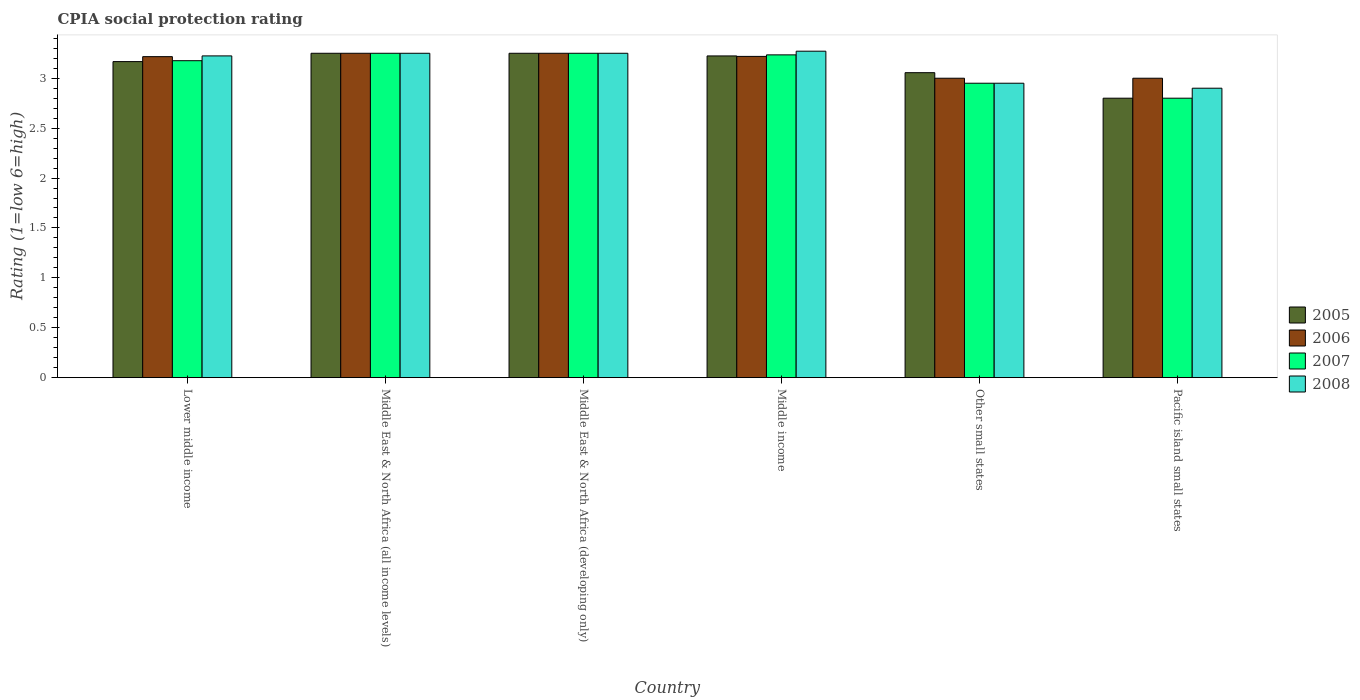How many different coloured bars are there?
Offer a terse response. 4. How many bars are there on the 1st tick from the left?
Ensure brevity in your answer.  4. What is the label of the 2nd group of bars from the left?
Provide a succinct answer. Middle East & North Africa (all income levels). In how many cases, is the number of bars for a given country not equal to the number of legend labels?
Keep it short and to the point. 0. What is the CPIA rating in 2005 in Middle income?
Keep it short and to the point. 3.22. In which country was the CPIA rating in 2008 maximum?
Provide a short and direct response. Middle income. In which country was the CPIA rating in 2006 minimum?
Offer a terse response. Other small states. What is the total CPIA rating in 2007 in the graph?
Keep it short and to the point. 18.66. What is the difference between the CPIA rating in 2008 in Middle East & North Africa (all income levels) and that in Middle East & North Africa (developing only)?
Your response must be concise. 0. What is the difference between the CPIA rating in 2007 in Lower middle income and the CPIA rating in 2006 in Middle income?
Provide a succinct answer. -0.04. What is the average CPIA rating in 2007 per country?
Make the answer very short. 3.11. What is the difference between the CPIA rating of/in 2006 and CPIA rating of/in 2008 in Middle income?
Offer a very short reply. -0.05. In how many countries, is the CPIA rating in 2005 greater than 0.8?
Give a very brief answer. 6. What is the ratio of the CPIA rating in 2005 in Other small states to that in Pacific island small states?
Provide a succinct answer. 1.09. What is the difference between the highest and the second highest CPIA rating in 2005?
Your answer should be very brief. -0.03. What is the difference between the highest and the lowest CPIA rating in 2007?
Offer a terse response. 0.45. Is the sum of the CPIA rating in 2006 in Middle East & North Africa (developing only) and Middle income greater than the maximum CPIA rating in 2008 across all countries?
Offer a very short reply. Yes. How many bars are there?
Your answer should be very brief. 24. Are all the bars in the graph horizontal?
Make the answer very short. No. What is the difference between two consecutive major ticks on the Y-axis?
Give a very brief answer. 0.5. Are the values on the major ticks of Y-axis written in scientific E-notation?
Your answer should be very brief. No. Does the graph contain any zero values?
Give a very brief answer. No. Does the graph contain grids?
Provide a short and direct response. No. Where does the legend appear in the graph?
Ensure brevity in your answer.  Center right. How many legend labels are there?
Provide a short and direct response. 4. What is the title of the graph?
Give a very brief answer. CPIA social protection rating. Does "2007" appear as one of the legend labels in the graph?
Offer a terse response. Yes. What is the label or title of the X-axis?
Provide a succinct answer. Country. What is the label or title of the Y-axis?
Provide a succinct answer. Rating (1=low 6=high). What is the Rating (1=low 6=high) of 2005 in Lower middle income?
Provide a short and direct response. 3.17. What is the Rating (1=low 6=high) of 2006 in Lower middle income?
Make the answer very short. 3.22. What is the Rating (1=low 6=high) of 2007 in Lower middle income?
Your response must be concise. 3.18. What is the Rating (1=low 6=high) in 2008 in Lower middle income?
Give a very brief answer. 3.22. What is the Rating (1=low 6=high) of 2007 in Middle East & North Africa (all income levels)?
Your answer should be very brief. 3.25. What is the Rating (1=low 6=high) in 2007 in Middle East & North Africa (developing only)?
Ensure brevity in your answer.  3.25. What is the Rating (1=low 6=high) of 2005 in Middle income?
Provide a succinct answer. 3.22. What is the Rating (1=low 6=high) of 2006 in Middle income?
Give a very brief answer. 3.22. What is the Rating (1=low 6=high) of 2007 in Middle income?
Your answer should be compact. 3.23. What is the Rating (1=low 6=high) of 2008 in Middle income?
Make the answer very short. 3.27. What is the Rating (1=low 6=high) in 2005 in Other small states?
Ensure brevity in your answer.  3.06. What is the Rating (1=low 6=high) of 2007 in Other small states?
Offer a terse response. 2.95. What is the Rating (1=low 6=high) of 2008 in Other small states?
Keep it short and to the point. 2.95. What is the Rating (1=low 6=high) of 2005 in Pacific island small states?
Provide a succinct answer. 2.8. What is the Rating (1=low 6=high) in 2008 in Pacific island small states?
Make the answer very short. 2.9. Across all countries, what is the maximum Rating (1=low 6=high) in 2005?
Offer a terse response. 3.25. Across all countries, what is the maximum Rating (1=low 6=high) of 2006?
Your answer should be very brief. 3.25. Across all countries, what is the maximum Rating (1=low 6=high) of 2007?
Offer a terse response. 3.25. Across all countries, what is the maximum Rating (1=low 6=high) of 2008?
Offer a terse response. 3.27. Across all countries, what is the minimum Rating (1=low 6=high) in 2006?
Your answer should be compact. 3. Across all countries, what is the minimum Rating (1=low 6=high) in 2007?
Your answer should be very brief. 2.8. Across all countries, what is the minimum Rating (1=low 6=high) in 2008?
Ensure brevity in your answer.  2.9. What is the total Rating (1=low 6=high) of 2005 in the graph?
Provide a succinct answer. 18.75. What is the total Rating (1=low 6=high) in 2006 in the graph?
Offer a terse response. 18.93. What is the total Rating (1=low 6=high) of 2007 in the graph?
Provide a succinct answer. 18.66. What is the total Rating (1=low 6=high) of 2008 in the graph?
Keep it short and to the point. 18.84. What is the difference between the Rating (1=low 6=high) in 2005 in Lower middle income and that in Middle East & North Africa (all income levels)?
Your answer should be compact. -0.08. What is the difference between the Rating (1=low 6=high) in 2006 in Lower middle income and that in Middle East & North Africa (all income levels)?
Make the answer very short. -0.03. What is the difference between the Rating (1=low 6=high) in 2007 in Lower middle income and that in Middle East & North Africa (all income levels)?
Offer a terse response. -0.07. What is the difference between the Rating (1=low 6=high) in 2008 in Lower middle income and that in Middle East & North Africa (all income levels)?
Offer a very short reply. -0.03. What is the difference between the Rating (1=low 6=high) of 2005 in Lower middle income and that in Middle East & North Africa (developing only)?
Give a very brief answer. -0.08. What is the difference between the Rating (1=low 6=high) of 2006 in Lower middle income and that in Middle East & North Africa (developing only)?
Ensure brevity in your answer.  -0.03. What is the difference between the Rating (1=low 6=high) of 2007 in Lower middle income and that in Middle East & North Africa (developing only)?
Ensure brevity in your answer.  -0.07. What is the difference between the Rating (1=low 6=high) of 2008 in Lower middle income and that in Middle East & North Africa (developing only)?
Keep it short and to the point. -0.03. What is the difference between the Rating (1=low 6=high) of 2005 in Lower middle income and that in Middle income?
Ensure brevity in your answer.  -0.06. What is the difference between the Rating (1=low 6=high) in 2006 in Lower middle income and that in Middle income?
Provide a short and direct response. -0. What is the difference between the Rating (1=low 6=high) in 2007 in Lower middle income and that in Middle income?
Your response must be concise. -0.06. What is the difference between the Rating (1=low 6=high) in 2008 in Lower middle income and that in Middle income?
Your answer should be very brief. -0.05. What is the difference between the Rating (1=low 6=high) in 2006 in Lower middle income and that in Other small states?
Make the answer very short. 0.22. What is the difference between the Rating (1=low 6=high) in 2007 in Lower middle income and that in Other small states?
Keep it short and to the point. 0.23. What is the difference between the Rating (1=low 6=high) in 2008 in Lower middle income and that in Other small states?
Your answer should be compact. 0.27. What is the difference between the Rating (1=low 6=high) of 2005 in Lower middle income and that in Pacific island small states?
Keep it short and to the point. 0.37. What is the difference between the Rating (1=low 6=high) of 2006 in Lower middle income and that in Pacific island small states?
Provide a short and direct response. 0.22. What is the difference between the Rating (1=low 6=high) of 2007 in Lower middle income and that in Pacific island small states?
Your answer should be compact. 0.38. What is the difference between the Rating (1=low 6=high) in 2008 in Lower middle income and that in Pacific island small states?
Offer a very short reply. 0.32. What is the difference between the Rating (1=low 6=high) in 2006 in Middle East & North Africa (all income levels) and that in Middle East & North Africa (developing only)?
Your answer should be compact. 0. What is the difference between the Rating (1=low 6=high) of 2005 in Middle East & North Africa (all income levels) and that in Middle income?
Give a very brief answer. 0.03. What is the difference between the Rating (1=low 6=high) of 2006 in Middle East & North Africa (all income levels) and that in Middle income?
Your response must be concise. 0.03. What is the difference between the Rating (1=low 6=high) of 2007 in Middle East & North Africa (all income levels) and that in Middle income?
Your answer should be very brief. 0.02. What is the difference between the Rating (1=low 6=high) of 2008 in Middle East & North Africa (all income levels) and that in Middle income?
Make the answer very short. -0.02. What is the difference between the Rating (1=low 6=high) in 2005 in Middle East & North Africa (all income levels) and that in Other small states?
Provide a succinct answer. 0.19. What is the difference between the Rating (1=low 6=high) of 2006 in Middle East & North Africa (all income levels) and that in Other small states?
Ensure brevity in your answer.  0.25. What is the difference between the Rating (1=low 6=high) in 2007 in Middle East & North Africa (all income levels) and that in Other small states?
Make the answer very short. 0.3. What is the difference between the Rating (1=low 6=high) of 2008 in Middle East & North Africa (all income levels) and that in Other small states?
Your answer should be compact. 0.3. What is the difference between the Rating (1=low 6=high) of 2005 in Middle East & North Africa (all income levels) and that in Pacific island small states?
Your response must be concise. 0.45. What is the difference between the Rating (1=low 6=high) in 2007 in Middle East & North Africa (all income levels) and that in Pacific island small states?
Ensure brevity in your answer.  0.45. What is the difference between the Rating (1=low 6=high) in 2008 in Middle East & North Africa (all income levels) and that in Pacific island small states?
Provide a short and direct response. 0.35. What is the difference between the Rating (1=low 6=high) of 2005 in Middle East & North Africa (developing only) and that in Middle income?
Offer a very short reply. 0.03. What is the difference between the Rating (1=low 6=high) of 2006 in Middle East & North Africa (developing only) and that in Middle income?
Give a very brief answer. 0.03. What is the difference between the Rating (1=low 6=high) in 2007 in Middle East & North Africa (developing only) and that in Middle income?
Keep it short and to the point. 0.02. What is the difference between the Rating (1=low 6=high) in 2008 in Middle East & North Africa (developing only) and that in Middle income?
Offer a terse response. -0.02. What is the difference between the Rating (1=low 6=high) of 2005 in Middle East & North Africa (developing only) and that in Other small states?
Give a very brief answer. 0.19. What is the difference between the Rating (1=low 6=high) of 2007 in Middle East & North Africa (developing only) and that in Other small states?
Ensure brevity in your answer.  0.3. What is the difference between the Rating (1=low 6=high) of 2008 in Middle East & North Africa (developing only) and that in Other small states?
Offer a terse response. 0.3. What is the difference between the Rating (1=low 6=high) of 2005 in Middle East & North Africa (developing only) and that in Pacific island small states?
Ensure brevity in your answer.  0.45. What is the difference between the Rating (1=low 6=high) in 2006 in Middle East & North Africa (developing only) and that in Pacific island small states?
Offer a terse response. 0.25. What is the difference between the Rating (1=low 6=high) of 2007 in Middle East & North Africa (developing only) and that in Pacific island small states?
Provide a succinct answer. 0.45. What is the difference between the Rating (1=low 6=high) in 2008 in Middle East & North Africa (developing only) and that in Pacific island small states?
Your answer should be compact. 0.35. What is the difference between the Rating (1=low 6=high) of 2005 in Middle income and that in Other small states?
Provide a short and direct response. 0.17. What is the difference between the Rating (1=low 6=high) in 2006 in Middle income and that in Other small states?
Provide a short and direct response. 0.22. What is the difference between the Rating (1=low 6=high) of 2007 in Middle income and that in Other small states?
Make the answer very short. 0.28. What is the difference between the Rating (1=low 6=high) of 2008 in Middle income and that in Other small states?
Ensure brevity in your answer.  0.32. What is the difference between the Rating (1=low 6=high) of 2005 in Middle income and that in Pacific island small states?
Your answer should be very brief. 0.42. What is the difference between the Rating (1=low 6=high) of 2006 in Middle income and that in Pacific island small states?
Give a very brief answer. 0.22. What is the difference between the Rating (1=low 6=high) of 2007 in Middle income and that in Pacific island small states?
Offer a very short reply. 0.43. What is the difference between the Rating (1=low 6=high) of 2008 in Middle income and that in Pacific island small states?
Your answer should be compact. 0.37. What is the difference between the Rating (1=low 6=high) of 2005 in Other small states and that in Pacific island small states?
Your answer should be very brief. 0.26. What is the difference between the Rating (1=low 6=high) in 2006 in Other small states and that in Pacific island small states?
Make the answer very short. 0. What is the difference between the Rating (1=low 6=high) in 2007 in Other small states and that in Pacific island small states?
Keep it short and to the point. 0.15. What is the difference between the Rating (1=low 6=high) of 2005 in Lower middle income and the Rating (1=low 6=high) of 2006 in Middle East & North Africa (all income levels)?
Make the answer very short. -0.08. What is the difference between the Rating (1=low 6=high) of 2005 in Lower middle income and the Rating (1=low 6=high) of 2007 in Middle East & North Africa (all income levels)?
Offer a terse response. -0.08. What is the difference between the Rating (1=low 6=high) of 2005 in Lower middle income and the Rating (1=low 6=high) of 2008 in Middle East & North Africa (all income levels)?
Give a very brief answer. -0.08. What is the difference between the Rating (1=low 6=high) of 2006 in Lower middle income and the Rating (1=low 6=high) of 2007 in Middle East & North Africa (all income levels)?
Provide a short and direct response. -0.03. What is the difference between the Rating (1=low 6=high) of 2006 in Lower middle income and the Rating (1=low 6=high) of 2008 in Middle East & North Africa (all income levels)?
Give a very brief answer. -0.03. What is the difference between the Rating (1=low 6=high) of 2007 in Lower middle income and the Rating (1=low 6=high) of 2008 in Middle East & North Africa (all income levels)?
Make the answer very short. -0.07. What is the difference between the Rating (1=low 6=high) in 2005 in Lower middle income and the Rating (1=low 6=high) in 2006 in Middle East & North Africa (developing only)?
Your response must be concise. -0.08. What is the difference between the Rating (1=low 6=high) in 2005 in Lower middle income and the Rating (1=low 6=high) in 2007 in Middle East & North Africa (developing only)?
Your answer should be very brief. -0.08. What is the difference between the Rating (1=low 6=high) in 2005 in Lower middle income and the Rating (1=low 6=high) in 2008 in Middle East & North Africa (developing only)?
Give a very brief answer. -0.08. What is the difference between the Rating (1=low 6=high) in 2006 in Lower middle income and the Rating (1=low 6=high) in 2007 in Middle East & North Africa (developing only)?
Your answer should be compact. -0.03. What is the difference between the Rating (1=low 6=high) of 2006 in Lower middle income and the Rating (1=low 6=high) of 2008 in Middle East & North Africa (developing only)?
Make the answer very short. -0.03. What is the difference between the Rating (1=low 6=high) of 2007 in Lower middle income and the Rating (1=low 6=high) of 2008 in Middle East & North Africa (developing only)?
Provide a succinct answer. -0.07. What is the difference between the Rating (1=low 6=high) of 2005 in Lower middle income and the Rating (1=low 6=high) of 2006 in Middle income?
Provide a short and direct response. -0.05. What is the difference between the Rating (1=low 6=high) of 2005 in Lower middle income and the Rating (1=low 6=high) of 2007 in Middle income?
Offer a very short reply. -0.07. What is the difference between the Rating (1=low 6=high) of 2005 in Lower middle income and the Rating (1=low 6=high) of 2008 in Middle income?
Give a very brief answer. -0.1. What is the difference between the Rating (1=low 6=high) of 2006 in Lower middle income and the Rating (1=low 6=high) of 2007 in Middle income?
Offer a terse response. -0.02. What is the difference between the Rating (1=low 6=high) in 2006 in Lower middle income and the Rating (1=low 6=high) in 2008 in Middle income?
Give a very brief answer. -0.05. What is the difference between the Rating (1=low 6=high) of 2007 in Lower middle income and the Rating (1=low 6=high) of 2008 in Middle income?
Your answer should be compact. -0.1. What is the difference between the Rating (1=low 6=high) of 2005 in Lower middle income and the Rating (1=low 6=high) of 2007 in Other small states?
Ensure brevity in your answer.  0.22. What is the difference between the Rating (1=low 6=high) in 2005 in Lower middle income and the Rating (1=low 6=high) in 2008 in Other small states?
Make the answer very short. 0.22. What is the difference between the Rating (1=low 6=high) of 2006 in Lower middle income and the Rating (1=low 6=high) of 2007 in Other small states?
Provide a short and direct response. 0.27. What is the difference between the Rating (1=low 6=high) of 2006 in Lower middle income and the Rating (1=low 6=high) of 2008 in Other small states?
Give a very brief answer. 0.27. What is the difference between the Rating (1=low 6=high) of 2007 in Lower middle income and the Rating (1=low 6=high) of 2008 in Other small states?
Offer a very short reply. 0.23. What is the difference between the Rating (1=low 6=high) in 2005 in Lower middle income and the Rating (1=low 6=high) in 2006 in Pacific island small states?
Make the answer very short. 0.17. What is the difference between the Rating (1=low 6=high) in 2005 in Lower middle income and the Rating (1=low 6=high) in 2007 in Pacific island small states?
Keep it short and to the point. 0.37. What is the difference between the Rating (1=low 6=high) in 2005 in Lower middle income and the Rating (1=low 6=high) in 2008 in Pacific island small states?
Your answer should be compact. 0.27. What is the difference between the Rating (1=low 6=high) of 2006 in Lower middle income and the Rating (1=low 6=high) of 2007 in Pacific island small states?
Offer a terse response. 0.42. What is the difference between the Rating (1=low 6=high) in 2006 in Lower middle income and the Rating (1=low 6=high) in 2008 in Pacific island small states?
Provide a short and direct response. 0.32. What is the difference between the Rating (1=low 6=high) in 2007 in Lower middle income and the Rating (1=low 6=high) in 2008 in Pacific island small states?
Offer a terse response. 0.28. What is the difference between the Rating (1=low 6=high) of 2006 in Middle East & North Africa (all income levels) and the Rating (1=low 6=high) of 2008 in Middle East & North Africa (developing only)?
Keep it short and to the point. 0. What is the difference between the Rating (1=low 6=high) of 2007 in Middle East & North Africa (all income levels) and the Rating (1=low 6=high) of 2008 in Middle East & North Africa (developing only)?
Make the answer very short. 0. What is the difference between the Rating (1=low 6=high) in 2005 in Middle East & North Africa (all income levels) and the Rating (1=low 6=high) in 2006 in Middle income?
Provide a short and direct response. 0.03. What is the difference between the Rating (1=low 6=high) of 2005 in Middle East & North Africa (all income levels) and the Rating (1=low 6=high) of 2007 in Middle income?
Your response must be concise. 0.02. What is the difference between the Rating (1=low 6=high) in 2005 in Middle East & North Africa (all income levels) and the Rating (1=low 6=high) in 2008 in Middle income?
Your response must be concise. -0.02. What is the difference between the Rating (1=low 6=high) of 2006 in Middle East & North Africa (all income levels) and the Rating (1=low 6=high) of 2007 in Middle income?
Make the answer very short. 0.02. What is the difference between the Rating (1=low 6=high) in 2006 in Middle East & North Africa (all income levels) and the Rating (1=low 6=high) in 2008 in Middle income?
Give a very brief answer. -0.02. What is the difference between the Rating (1=low 6=high) in 2007 in Middle East & North Africa (all income levels) and the Rating (1=low 6=high) in 2008 in Middle income?
Offer a terse response. -0.02. What is the difference between the Rating (1=low 6=high) of 2005 in Middle East & North Africa (all income levels) and the Rating (1=low 6=high) of 2006 in Other small states?
Offer a terse response. 0.25. What is the difference between the Rating (1=low 6=high) of 2005 in Middle East & North Africa (all income levels) and the Rating (1=low 6=high) of 2007 in Other small states?
Provide a succinct answer. 0.3. What is the difference between the Rating (1=low 6=high) in 2006 in Middle East & North Africa (all income levels) and the Rating (1=low 6=high) in 2007 in Other small states?
Ensure brevity in your answer.  0.3. What is the difference between the Rating (1=low 6=high) of 2006 in Middle East & North Africa (all income levels) and the Rating (1=low 6=high) of 2008 in Other small states?
Keep it short and to the point. 0.3. What is the difference between the Rating (1=low 6=high) in 2005 in Middle East & North Africa (all income levels) and the Rating (1=low 6=high) in 2007 in Pacific island small states?
Your answer should be very brief. 0.45. What is the difference between the Rating (1=low 6=high) of 2006 in Middle East & North Africa (all income levels) and the Rating (1=low 6=high) of 2007 in Pacific island small states?
Your response must be concise. 0.45. What is the difference between the Rating (1=low 6=high) in 2007 in Middle East & North Africa (all income levels) and the Rating (1=low 6=high) in 2008 in Pacific island small states?
Give a very brief answer. 0.35. What is the difference between the Rating (1=low 6=high) in 2005 in Middle East & North Africa (developing only) and the Rating (1=low 6=high) in 2006 in Middle income?
Offer a very short reply. 0.03. What is the difference between the Rating (1=low 6=high) in 2005 in Middle East & North Africa (developing only) and the Rating (1=low 6=high) in 2007 in Middle income?
Provide a short and direct response. 0.02. What is the difference between the Rating (1=low 6=high) in 2005 in Middle East & North Africa (developing only) and the Rating (1=low 6=high) in 2008 in Middle income?
Provide a short and direct response. -0.02. What is the difference between the Rating (1=low 6=high) of 2006 in Middle East & North Africa (developing only) and the Rating (1=low 6=high) of 2007 in Middle income?
Ensure brevity in your answer.  0.02. What is the difference between the Rating (1=low 6=high) of 2006 in Middle East & North Africa (developing only) and the Rating (1=low 6=high) of 2008 in Middle income?
Offer a terse response. -0.02. What is the difference between the Rating (1=low 6=high) of 2007 in Middle East & North Africa (developing only) and the Rating (1=low 6=high) of 2008 in Middle income?
Provide a short and direct response. -0.02. What is the difference between the Rating (1=low 6=high) of 2005 in Middle East & North Africa (developing only) and the Rating (1=low 6=high) of 2006 in Other small states?
Your answer should be very brief. 0.25. What is the difference between the Rating (1=low 6=high) in 2005 in Middle East & North Africa (developing only) and the Rating (1=low 6=high) in 2007 in Other small states?
Your response must be concise. 0.3. What is the difference between the Rating (1=low 6=high) of 2007 in Middle East & North Africa (developing only) and the Rating (1=low 6=high) of 2008 in Other small states?
Provide a short and direct response. 0.3. What is the difference between the Rating (1=low 6=high) of 2005 in Middle East & North Africa (developing only) and the Rating (1=low 6=high) of 2006 in Pacific island small states?
Offer a very short reply. 0.25. What is the difference between the Rating (1=low 6=high) of 2005 in Middle East & North Africa (developing only) and the Rating (1=low 6=high) of 2007 in Pacific island small states?
Provide a short and direct response. 0.45. What is the difference between the Rating (1=low 6=high) in 2006 in Middle East & North Africa (developing only) and the Rating (1=low 6=high) in 2007 in Pacific island small states?
Keep it short and to the point. 0.45. What is the difference between the Rating (1=low 6=high) in 2006 in Middle East & North Africa (developing only) and the Rating (1=low 6=high) in 2008 in Pacific island small states?
Your response must be concise. 0.35. What is the difference between the Rating (1=low 6=high) in 2005 in Middle income and the Rating (1=low 6=high) in 2006 in Other small states?
Offer a terse response. 0.22. What is the difference between the Rating (1=low 6=high) of 2005 in Middle income and the Rating (1=low 6=high) of 2007 in Other small states?
Ensure brevity in your answer.  0.27. What is the difference between the Rating (1=low 6=high) in 2005 in Middle income and the Rating (1=low 6=high) in 2008 in Other small states?
Your answer should be very brief. 0.27. What is the difference between the Rating (1=low 6=high) in 2006 in Middle income and the Rating (1=low 6=high) in 2007 in Other small states?
Provide a succinct answer. 0.27. What is the difference between the Rating (1=low 6=high) in 2006 in Middle income and the Rating (1=low 6=high) in 2008 in Other small states?
Keep it short and to the point. 0.27. What is the difference between the Rating (1=low 6=high) of 2007 in Middle income and the Rating (1=low 6=high) of 2008 in Other small states?
Provide a short and direct response. 0.28. What is the difference between the Rating (1=low 6=high) of 2005 in Middle income and the Rating (1=low 6=high) of 2006 in Pacific island small states?
Give a very brief answer. 0.22. What is the difference between the Rating (1=low 6=high) in 2005 in Middle income and the Rating (1=low 6=high) in 2007 in Pacific island small states?
Offer a terse response. 0.42. What is the difference between the Rating (1=low 6=high) in 2005 in Middle income and the Rating (1=low 6=high) in 2008 in Pacific island small states?
Make the answer very short. 0.32. What is the difference between the Rating (1=low 6=high) of 2006 in Middle income and the Rating (1=low 6=high) of 2007 in Pacific island small states?
Keep it short and to the point. 0.42. What is the difference between the Rating (1=low 6=high) in 2006 in Middle income and the Rating (1=low 6=high) in 2008 in Pacific island small states?
Provide a succinct answer. 0.32. What is the difference between the Rating (1=low 6=high) in 2007 in Middle income and the Rating (1=low 6=high) in 2008 in Pacific island small states?
Provide a succinct answer. 0.33. What is the difference between the Rating (1=low 6=high) of 2005 in Other small states and the Rating (1=low 6=high) of 2006 in Pacific island small states?
Your answer should be very brief. 0.06. What is the difference between the Rating (1=low 6=high) in 2005 in Other small states and the Rating (1=low 6=high) in 2007 in Pacific island small states?
Your answer should be compact. 0.26. What is the difference between the Rating (1=low 6=high) in 2005 in Other small states and the Rating (1=low 6=high) in 2008 in Pacific island small states?
Provide a succinct answer. 0.16. What is the difference between the Rating (1=low 6=high) of 2006 in Other small states and the Rating (1=low 6=high) of 2008 in Pacific island small states?
Give a very brief answer. 0.1. What is the difference between the Rating (1=low 6=high) in 2007 in Other small states and the Rating (1=low 6=high) in 2008 in Pacific island small states?
Keep it short and to the point. 0.05. What is the average Rating (1=low 6=high) in 2005 per country?
Your response must be concise. 3.12. What is the average Rating (1=low 6=high) of 2006 per country?
Ensure brevity in your answer.  3.16. What is the average Rating (1=low 6=high) in 2007 per country?
Ensure brevity in your answer.  3.11. What is the average Rating (1=low 6=high) in 2008 per country?
Your response must be concise. 3.14. What is the difference between the Rating (1=low 6=high) in 2005 and Rating (1=low 6=high) in 2006 in Lower middle income?
Offer a very short reply. -0.05. What is the difference between the Rating (1=low 6=high) of 2005 and Rating (1=low 6=high) of 2007 in Lower middle income?
Your answer should be very brief. -0.01. What is the difference between the Rating (1=low 6=high) of 2005 and Rating (1=low 6=high) of 2008 in Lower middle income?
Give a very brief answer. -0.06. What is the difference between the Rating (1=low 6=high) in 2006 and Rating (1=low 6=high) in 2007 in Lower middle income?
Keep it short and to the point. 0.04. What is the difference between the Rating (1=low 6=high) in 2006 and Rating (1=low 6=high) in 2008 in Lower middle income?
Provide a short and direct response. -0.01. What is the difference between the Rating (1=low 6=high) in 2007 and Rating (1=low 6=high) in 2008 in Lower middle income?
Make the answer very short. -0.05. What is the difference between the Rating (1=low 6=high) of 2005 and Rating (1=low 6=high) of 2006 in Middle East & North Africa (all income levels)?
Make the answer very short. 0. What is the difference between the Rating (1=low 6=high) of 2005 and Rating (1=low 6=high) of 2007 in Middle East & North Africa (all income levels)?
Ensure brevity in your answer.  0. What is the difference between the Rating (1=low 6=high) of 2005 and Rating (1=low 6=high) of 2008 in Middle East & North Africa (all income levels)?
Provide a succinct answer. 0. What is the difference between the Rating (1=low 6=high) of 2005 and Rating (1=low 6=high) of 2006 in Middle East & North Africa (developing only)?
Provide a short and direct response. 0. What is the difference between the Rating (1=low 6=high) in 2006 and Rating (1=low 6=high) in 2007 in Middle East & North Africa (developing only)?
Provide a succinct answer. 0. What is the difference between the Rating (1=low 6=high) of 2006 and Rating (1=low 6=high) of 2008 in Middle East & North Africa (developing only)?
Keep it short and to the point. 0. What is the difference between the Rating (1=low 6=high) in 2007 and Rating (1=low 6=high) in 2008 in Middle East & North Africa (developing only)?
Provide a succinct answer. 0. What is the difference between the Rating (1=low 6=high) in 2005 and Rating (1=low 6=high) in 2006 in Middle income?
Your answer should be very brief. 0. What is the difference between the Rating (1=low 6=high) in 2005 and Rating (1=low 6=high) in 2007 in Middle income?
Ensure brevity in your answer.  -0.01. What is the difference between the Rating (1=low 6=high) of 2005 and Rating (1=low 6=high) of 2008 in Middle income?
Offer a terse response. -0.05. What is the difference between the Rating (1=low 6=high) in 2006 and Rating (1=low 6=high) in 2007 in Middle income?
Give a very brief answer. -0.02. What is the difference between the Rating (1=low 6=high) in 2006 and Rating (1=low 6=high) in 2008 in Middle income?
Offer a very short reply. -0.05. What is the difference between the Rating (1=low 6=high) in 2007 and Rating (1=low 6=high) in 2008 in Middle income?
Ensure brevity in your answer.  -0.04. What is the difference between the Rating (1=low 6=high) of 2005 and Rating (1=low 6=high) of 2006 in Other small states?
Keep it short and to the point. 0.06. What is the difference between the Rating (1=low 6=high) in 2005 and Rating (1=low 6=high) in 2007 in Other small states?
Your response must be concise. 0.11. What is the difference between the Rating (1=low 6=high) in 2005 and Rating (1=low 6=high) in 2008 in Other small states?
Offer a terse response. 0.11. What is the difference between the Rating (1=low 6=high) in 2005 and Rating (1=low 6=high) in 2006 in Pacific island small states?
Give a very brief answer. -0.2. What is the difference between the Rating (1=low 6=high) in 2005 and Rating (1=low 6=high) in 2008 in Pacific island small states?
Provide a succinct answer. -0.1. What is the difference between the Rating (1=low 6=high) of 2006 and Rating (1=low 6=high) of 2007 in Pacific island small states?
Your answer should be very brief. 0.2. What is the difference between the Rating (1=low 6=high) in 2007 and Rating (1=low 6=high) in 2008 in Pacific island small states?
Make the answer very short. -0.1. What is the ratio of the Rating (1=low 6=high) of 2005 in Lower middle income to that in Middle East & North Africa (all income levels)?
Provide a short and direct response. 0.97. What is the ratio of the Rating (1=low 6=high) of 2006 in Lower middle income to that in Middle East & North Africa (all income levels)?
Your response must be concise. 0.99. What is the ratio of the Rating (1=low 6=high) of 2007 in Lower middle income to that in Middle East & North Africa (all income levels)?
Provide a succinct answer. 0.98. What is the ratio of the Rating (1=low 6=high) of 2008 in Lower middle income to that in Middle East & North Africa (all income levels)?
Your response must be concise. 0.99. What is the ratio of the Rating (1=low 6=high) in 2005 in Lower middle income to that in Middle East & North Africa (developing only)?
Provide a short and direct response. 0.97. What is the ratio of the Rating (1=low 6=high) of 2007 in Lower middle income to that in Middle East & North Africa (developing only)?
Provide a succinct answer. 0.98. What is the ratio of the Rating (1=low 6=high) in 2005 in Lower middle income to that in Middle income?
Your answer should be compact. 0.98. What is the ratio of the Rating (1=low 6=high) of 2006 in Lower middle income to that in Middle income?
Your response must be concise. 1. What is the ratio of the Rating (1=low 6=high) of 2008 in Lower middle income to that in Middle income?
Keep it short and to the point. 0.99. What is the ratio of the Rating (1=low 6=high) in 2005 in Lower middle income to that in Other small states?
Ensure brevity in your answer.  1.04. What is the ratio of the Rating (1=low 6=high) in 2006 in Lower middle income to that in Other small states?
Provide a short and direct response. 1.07. What is the ratio of the Rating (1=low 6=high) in 2007 in Lower middle income to that in Other small states?
Your answer should be very brief. 1.08. What is the ratio of the Rating (1=low 6=high) of 2008 in Lower middle income to that in Other small states?
Ensure brevity in your answer.  1.09. What is the ratio of the Rating (1=low 6=high) in 2005 in Lower middle income to that in Pacific island small states?
Your answer should be compact. 1.13. What is the ratio of the Rating (1=low 6=high) of 2006 in Lower middle income to that in Pacific island small states?
Provide a short and direct response. 1.07. What is the ratio of the Rating (1=low 6=high) of 2007 in Lower middle income to that in Pacific island small states?
Make the answer very short. 1.13. What is the ratio of the Rating (1=low 6=high) of 2008 in Lower middle income to that in Pacific island small states?
Offer a terse response. 1.11. What is the ratio of the Rating (1=low 6=high) of 2005 in Middle East & North Africa (all income levels) to that in Middle East & North Africa (developing only)?
Make the answer very short. 1. What is the ratio of the Rating (1=low 6=high) in 2005 in Middle East & North Africa (all income levels) to that in Middle income?
Provide a succinct answer. 1.01. What is the ratio of the Rating (1=low 6=high) of 2006 in Middle East & North Africa (all income levels) to that in Middle income?
Keep it short and to the point. 1.01. What is the ratio of the Rating (1=low 6=high) of 2007 in Middle East & North Africa (all income levels) to that in Middle income?
Offer a very short reply. 1. What is the ratio of the Rating (1=low 6=high) of 2008 in Middle East & North Africa (all income levels) to that in Middle income?
Provide a short and direct response. 0.99. What is the ratio of the Rating (1=low 6=high) in 2005 in Middle East & North Africa (all income levels) to that in Other small states?
Offer a very short reply. 1.06. What is the ratio of the Rating (1=low 6=high) in 2007 in Middle East & North Africa (all income levels) to that in Other small states?
Your answer should be compact. 1.1. What is the ratio of the Rating (1=low 6=high) in 2008 in Middle East & North Africa (all income levels) to that in Other small states?
Ensure brevity in your answer.  1.1. What is the ratio of the Rating (1=low 6=high) of 2005 in Middle East & North Africa (all income levels) to that in Pacific island small states?
Ensure brevity in your answer.  1.16. What is the ratio of the Rating (1=low 6=high) of 2007 in Middle East & North Africa (all income levels) to that in Pacific island small states?
Your response must be concise. 1.16. What is the ratio of the Rating (1=low 6=high) in 2008 in Middle East & North Africa (all income levels) to that in Pacific island small states?
Your answer should be very brief. 1.12. What is the ratio of the Rating (1=low 6=high) in 2005 in Middle East & North Africa (developing only) to that in Middle income?
Provide a succinct answer. 1.01. What is the ratio of the Rating (1=low 6=high) in 2006 in Middle East & North Africa (developing only) to that in Middle income?
Provide a succinct answer. 1.01. What is the ratio of the Rating (1=low 6=high) of 2007 in Middle East & North Africa (developing only) to that in Middle income?
Keep it short and to the point. 1. What is the ratio of the Rating (1=low 6=high) in 2008 in Middle East & North Africa (developing only) to that in Middle income?
Provide a short and direct response. 0.99. What is the ratio of the Rating (1=low 6=high) in 2005 in Middle East & North Africa (developing only) to that in Other small states?
Your response must be concise. 1.06. What is the ratio of the Rating (1=low 6=high) in 2006 in Middle East & North Africa (developing only) to that in Other small states?
Make the answer very short. 1.08. What is the ratio of the Rating (1=low 6=high) in 2007 in Middle East & North Africa (developing only) to that in Other small states?
Offer a very short reply. 1.1. What is the ratio of the Rating (1=low 6=high) in 2008 in Middle East & North Africa (developing only) to that in Other small states?
Provide a short and direct response. 1.1. What is the ratio of the Rating (1=low 6=high) in 2005 in Middle East & North Africa (developing only) to that in Pacific island small states?
Your response must be concise. 1.16. What is the ratio of the Rating (1=low 6=high) of 2007 in Middle East & North Africa (developing only) to that in Pacific island small states?
Provide a succinct answer. 1.16. What is the ratio of the Rating (1=low 6=high) of 2008 in Middle East & North Africa (developing only) to that in Pacific island small states?
Provide a succinct answer. 1.12. What is the ratio of the Rating (1=low 6=high) in 2005 in Middle income to that in Other small states?
Offer a very short reply. 1.05. What is the ratio of the Rating (1=low 6=high) in 2006 in Middle income to that in Other small states?
Give a very brief answer. 1.07. What is the ratio of the Rating (1=low 6=high) in 2007 in Middle income to that in Other small states?
Make the answer very short. 1.1. What is the ratio of the Rating (1=low 6=high) of 2008 in Middle income to that in Other small states?
Ensure brevity in your answer.  1.11. What is the ratio of the Rating (1=low 6=high) of 2005 in Middle income to that in Pacific island small states?
Your answer should be compact. 1.15. What is the ratio of the Rating (1=low 6=high) in 2006 in Middle income to that in Pacific island small states?
Your response must be concise. 1.07. What is the ratio of the Rating (1=low 6=high) in 2007 in Middle income to that in Pacific island small states?
Offer a very short reply. 1.16. What is the ratio of the Rating (1=low 6=high) of 2008 in Middle income to that in Pacific island small states?
Provide a succinct answer. 1.13. What is the ratio of the Rating (1=low 6=high) in 2005 in Other small states to that in Pacific island small states?
Provide a succinct answer. 1.09. What is the ratio of the Rating (1=low 6=high) of 2007 in Other small states to that in Pacific island small states?
Your answer should be compact. 1.05. What is the ratio of the Rating (1=low 6=high) of 2008 in Other small states to that in Pacific island small states?
Ensure brevity in your answer.  1.02. What is the difference between the highest and the second highest Rating (1=low 6=high) of 2006?
Ensure brevity in your answer.  0. What is the difference between the highest and the second highest Rating (1=low 6=high) of 2008?
Provide a short and direct response. 0.02. What is the difference between the highest and the lowest Rating (1=low 6=high) in 2005?
Your response must be concise. 0.45. What is the difference between the highest and the lowest Rating (1=low 6=high) in 2007?
Ensure brevity in your answer.  0.45. What is the difference between the highest and the lowest Rating (1=low 6=high) in 2008?
Give a very brief answer. 0.37. 